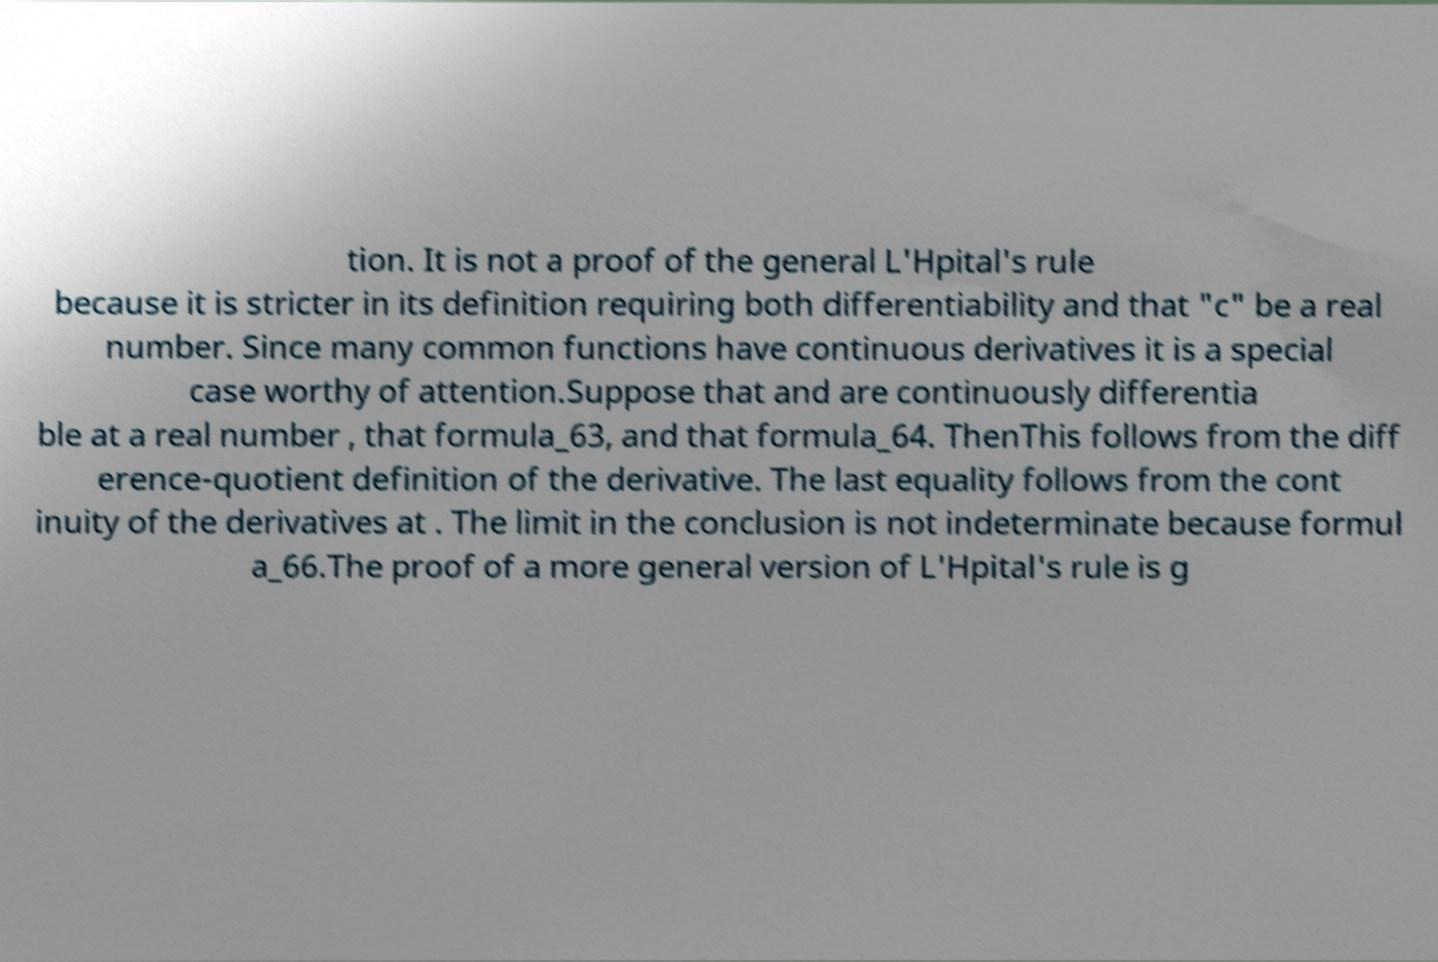Please identify and transcribe the text found in this image. tion. It is not a proof of the general L'Hpital's rule because it is stricter in its definition requiring both differentiability and that "c" be a real number. Since many common functions have continuous derivatives it is a special case worthy of attention.Suppose that and are continuously differentia ble at a real number , that formula_63, and that formula_64. ThenThis follows from the diff erence-quotient definition of the derivative. The last equality follows from the cont inuity of the derivatives at . The limit in the conclusion is not indeterminate because formul a_66.The proof of a more general version of L'Hpital's rule is g 